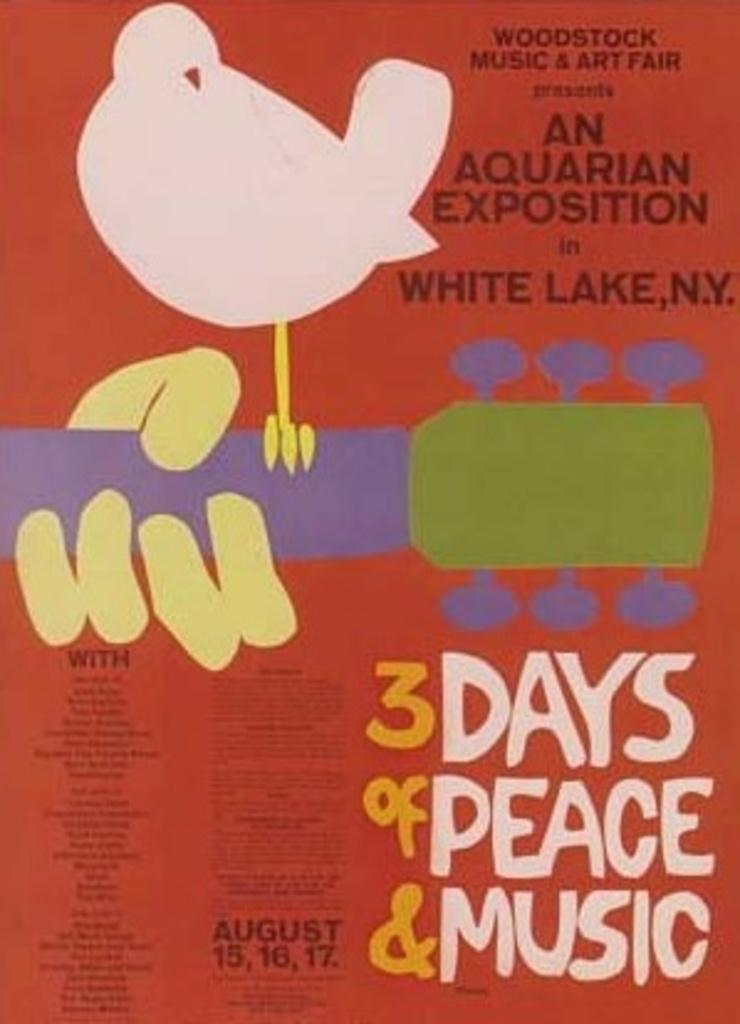What is the main subject of the poster in the image? The main subject of the poster is a person's hand holding a guitar. What additional element is present on the guitar? There is a bird standing on the guitar. What else can be seen on the poster besides the guitar and the bird? There are letters on the poster. What type of zephyr can be seen in the image? There is no zephyr present in the image. 